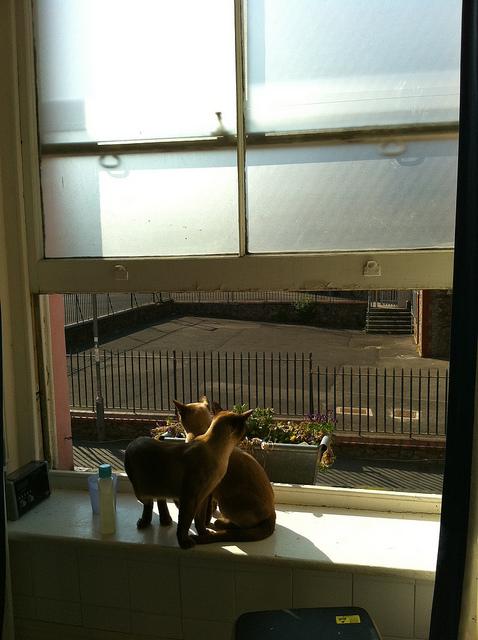Is that an adult cat?
Be succinct. Yes. Many women with mental issues acquire too many of these, two of which are shown here?
Write a very short answer. Cats. Is it raining?
Short answer required. No. Is the window new?
Be succinct. No. Is it sunny?
Write a very short answer. Yes. 